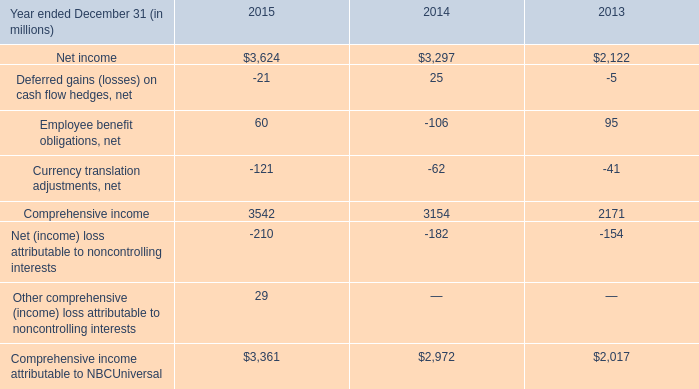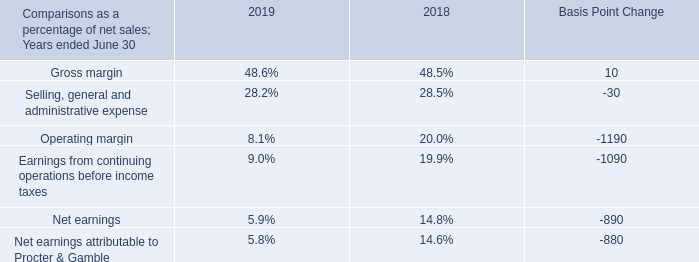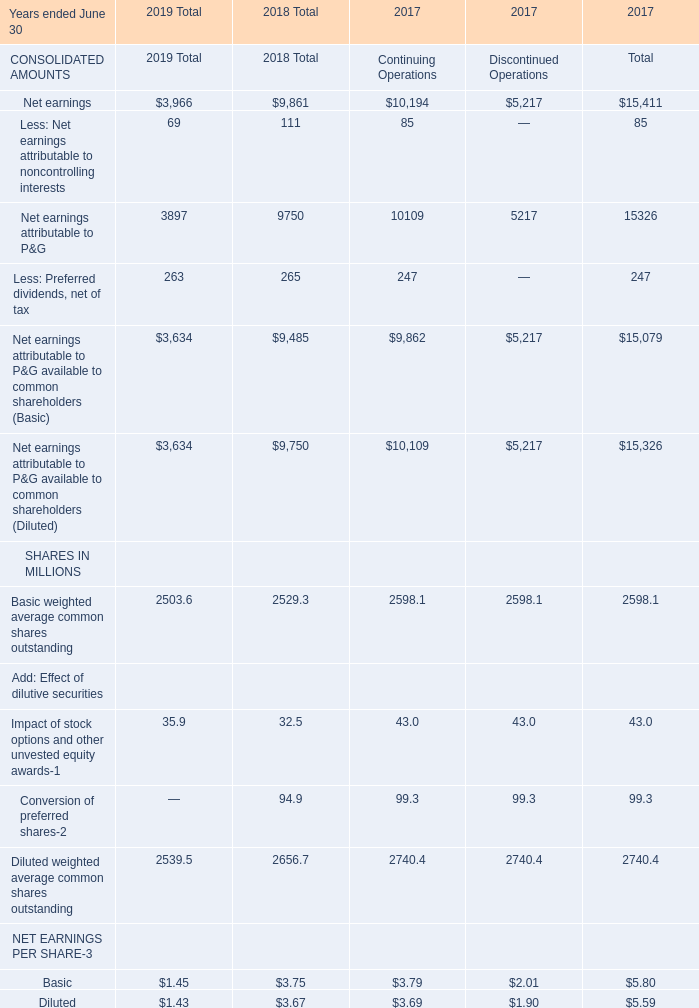what is the percentage change in comprehensive income attributable to nbcuniversal from 2013 to 2014? 
Computations: ((2972 - 2017) / 2017)
Answer: 0.47348. 